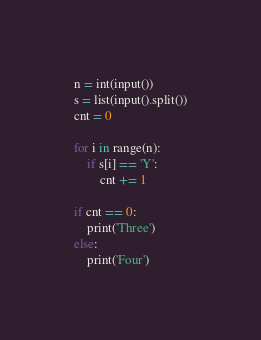<code> <loc_0><loc_0><loc_500><loc_500><_Python_>n = int(input())
s = list(input().split())
cnt = 0

for i in range(n):
    if s[i] == 'Y':
        cnt += 1

if cnt == 0:
    print('Three')
else:
    print('Four')</code> 